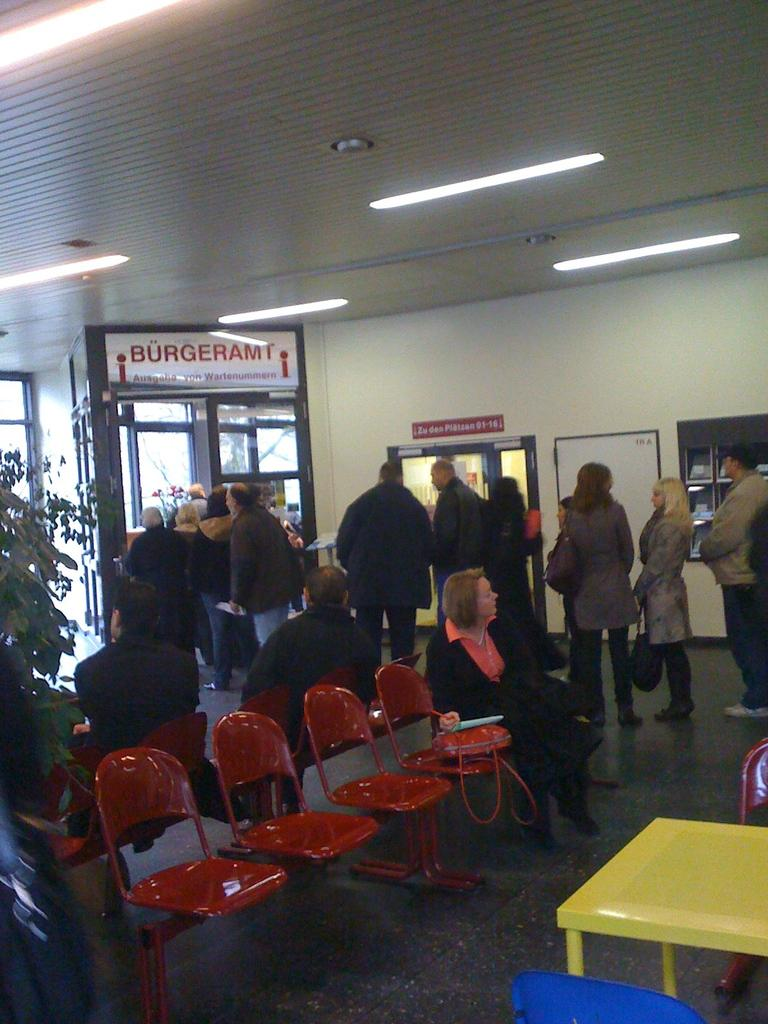What is happening with the group of people in the image? The group of people is standing on the floor in the image. What can be seen on the left side of the image? There is a plant on the left side of the image. What is located at the top of the image? There is a roof with lights at the top of the image. How many toes can be seen on the tiger in the image? There is no tiger present in the image, so it is not possible to determine the number of toes. 